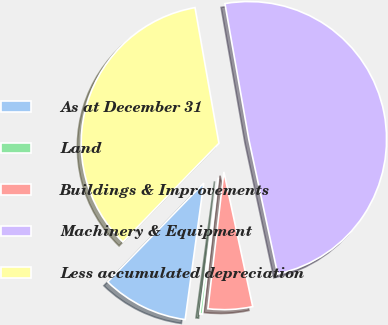Convert chart. <chart><loc_0><loc_0><loc_500><loc_500><pie_chart><fcel>As at December 31<fcel>Land<fcel>Buildings & Improvements<fcel>Machinery & Equipment<fcel>Less accumulated depreciation<nl><fcel>10.12%<fcel>0.3%<fcel>5.21%<fcel>49.41%<fcel>34.95%<nl></chart> 